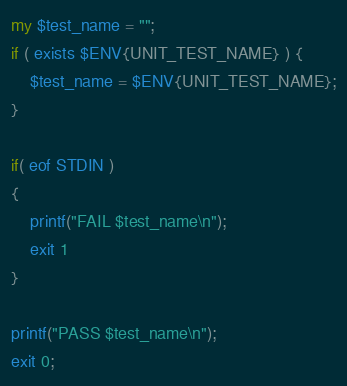Convert code to text. <code><loc_0><loc_0><loc_500><loc_500><_Perl_>my $test_name = "";
if ( exists $ENV{UNIT_TEST_NAME} ) {
	$test_name = $ENV{UNIT_TEST_NAME};
}

if( eof STDIN )
{
    printf("FAIL $test_name\n");
    exit 1
}

printf("PASS $test_name\n");
exit 0;

</code> 